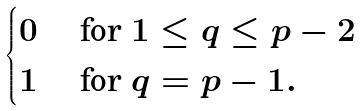Convert formula to latex. <formula><loc_0><loc_0><loc_500><loc_500>\begin{cases} 0 & \text { for } 1 \leq q \leq p - 2 \\ 1 & \text { for } q = p - 1 . \end{cases}</formula> 